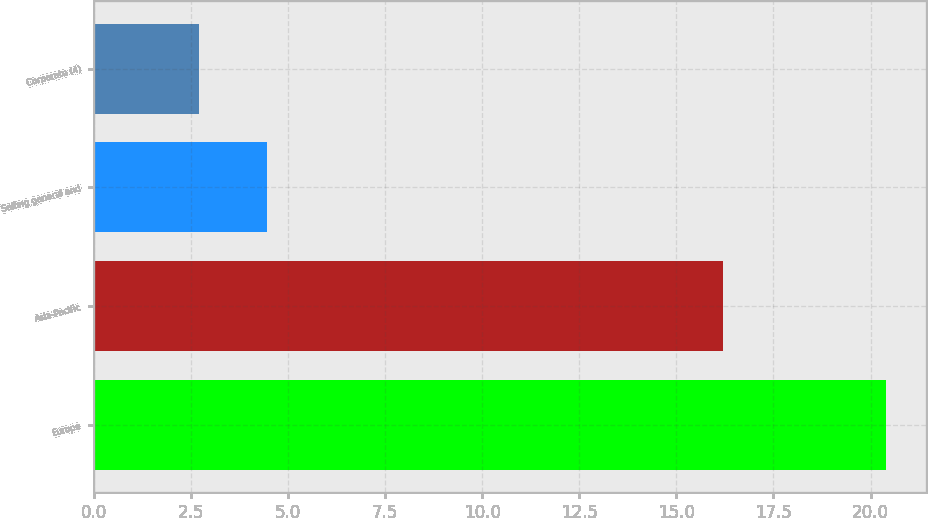Convert chart to OTSL. <chart><loc_0><loc_0><loc_500><loc_500><bar_chart><fcel>Europe<fcel>Asia-Pacific<fcel>Selling general and<fcel>Corporate (4)<nl><fcel>20.4<fcel>16.2<fcel>4.47<fcel>2.7<nl></chart> 